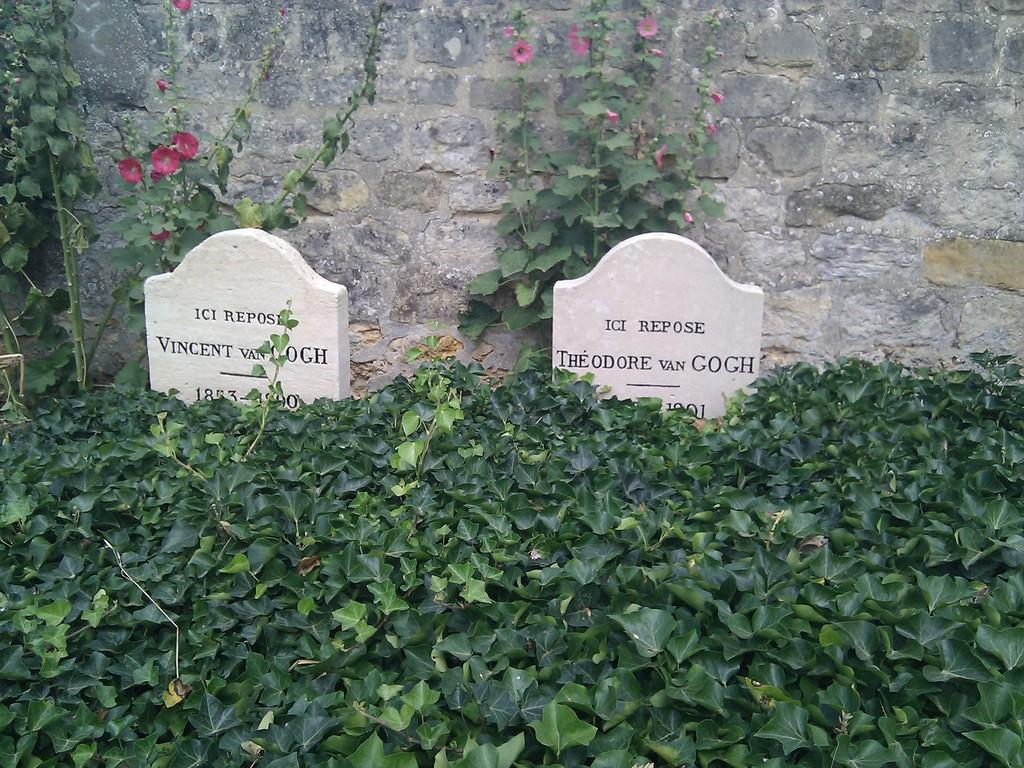<image>
Summarize the visual content of the image. Grave markers for members of the Van Gogh family sit among green plants. 